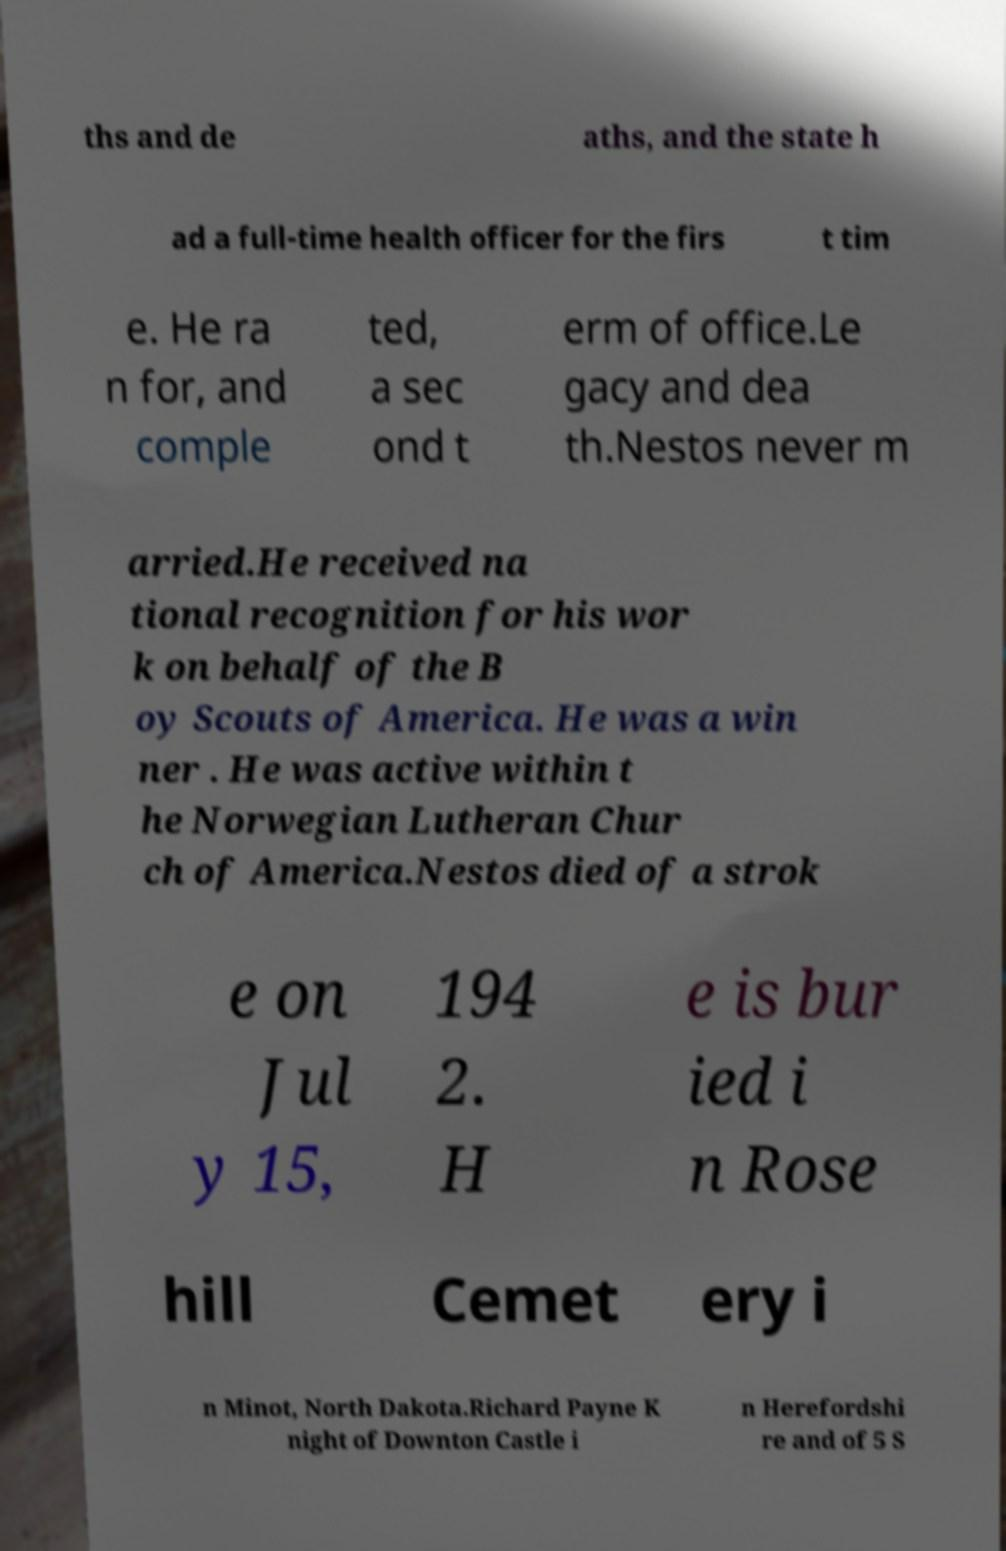Can you accurately transcribe the text from the provided image for me? ths and de aths, and the state h ad a full-time health officer for the firs t tim e. He ra n for, and comple ted, a sec ond t erm of office.Le gacy and dea th.Nestos never m arried.He received na tional recognition for his wor k on behalf of the B oy Scouts of America. He was a win ner . He was active within t he Norwegian Lutheran Chur ch of America.Nestos died of a strok e on Jul y 15, 194 2. H e is bur ied i n Rose hill Cemet ery i n Minot, North Dakota.Richard Payne K night of Downton Castle i n Herefordshi re and of 5 S 